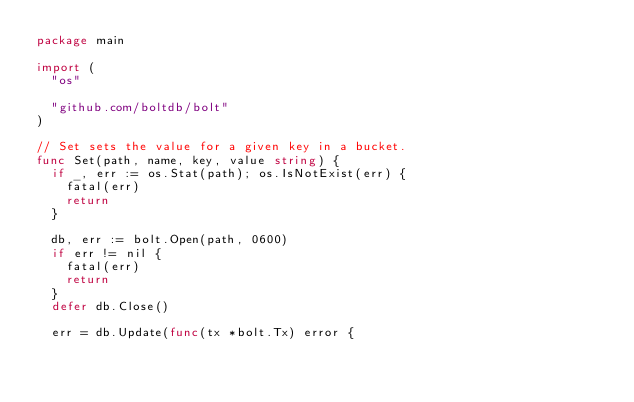Convert code to text. <code><loc_0><loc_0><loc_500><loc_500><_Go_>package main

import (
	"os"

	"github.com/boltdb/bolt"
)

// Set sets the value for a given key in a bucket.
func Set(path, name, key, value string) {
	if _, err := os.Stat(path); os.IsNotExist(err) {
		fatal(err)
		return
	}

	db, err := bolt.Open(path, 0600)
	if err != nil {
		fatal(err)
		return
	}
	defer db.Close()

	err = db.Update(func(tx *bolt.Tx) error {</code> 